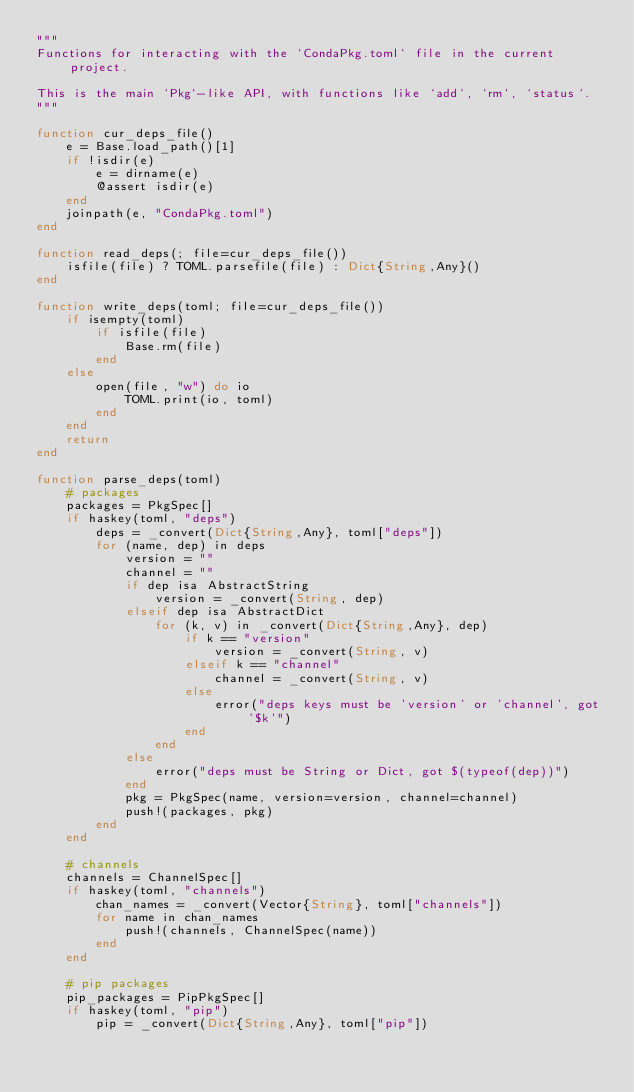Convert code to text. <code><loc_0><loc_0><loc_500><loc_500><_Julia_>"""
Functions for interacting with the `CondaPkg.toml` file in the current project.

This is the main `Pkg`-like API, with functions like `add`, `rm`, `status`.
"""

function cur_deps_file()
    e = Base.load_path()[1]
    if !isdir(e)
        e = dirname(e)
        @assert isdir(e)
    end
    joinpath(e, "CondaPkg.toml")
end

function read_deps(; file=cur_deps_file())
    isfile(file) ? TOML.parsefile(file) : Dict{String,Any}()
end

function write_deps(toml; file=cur_deps_file())
    if isempty(toml)
        if isfile(file)
            Base.rm(file)
        end
    else
        open(file, "w") do io
            TOML.print(io, toml)
        end
    end
    return
end

function parse_deps(toml)
    # packages
    packages = PkgSpec[]
    if haskey(toml, "deps")
        deps = _convert(Dict{String,Any}, toml["deps"])
        for (name, dep) in deps
            version = ""
            channel = ""
            if dep isa AbstractString
                version = _convert(String, dep)
            elseif dep isa AbstractDict
                for (k, v) in _convert(Dict{String,Any}, dep)
                    if k == "version"
                        version = _convert(String, v)
                    elseif k == "channel"
                        channel = _convert(String, v)
                    else
                        error("deps keys must be 'version' or 'channel', got '$k'")
                    end
                end
            else
                error("deps must be String or Dict, got $(typeof(dep))")
            end
            pkg = PkgSpec(name, version=version, channel=channel)
            push!(packages, pkg)
        end
    end

    # channels
    channels = ChannelSpec[]
    if haskey(toml, "channels")
        chan_names = _convert(Vector{String}, toml["channels"])
        for name in chan_names
            push!(channels, ChannelSpec(name))
        end
    end

    # pip packages
    pip_packages = PipPkgSpec[]
    if haskey(toml, "pip")
        pip = _convert(Dict{String,Any}, toml["pip"])</code> 